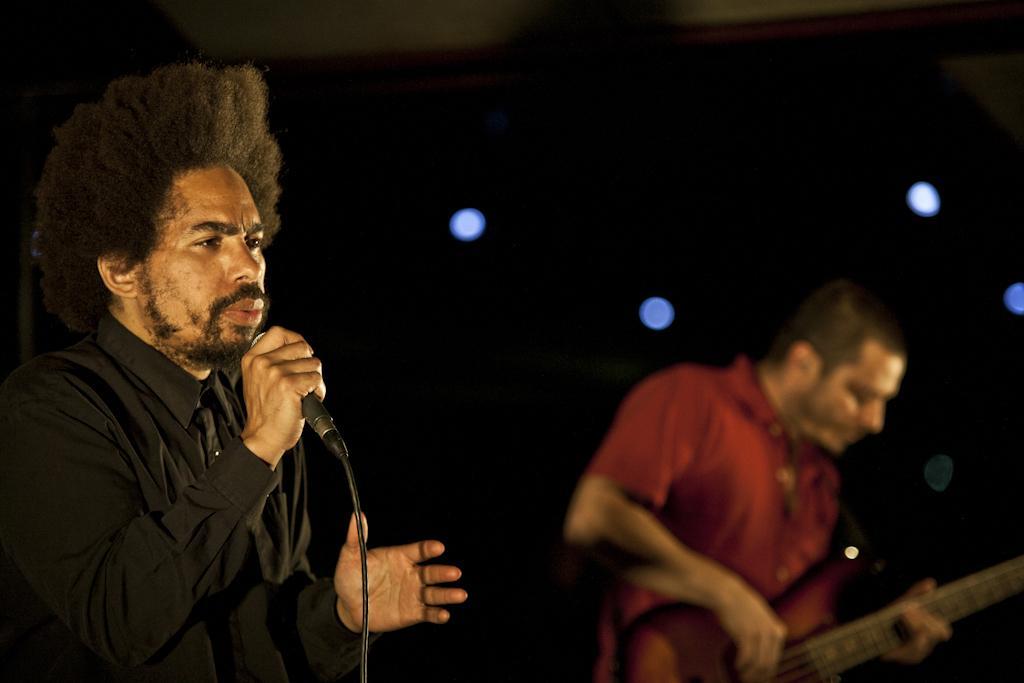Can you describe this image briefly? In this picture we can see two men where one is holding mic in his hand and singing and other holding guitar in his hand and playing it and in background we can see light and it is dark. 